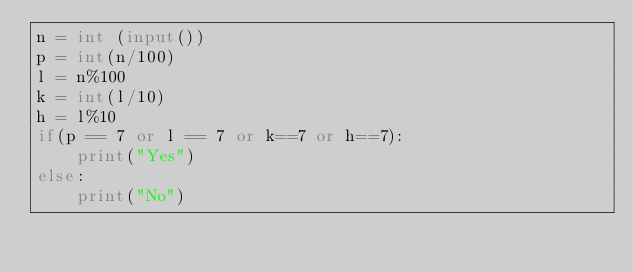Convert code to text. <code><loc_0><loc_0><loc_500><loc_500><_Python_>n = int (input())
p = int(n/100)
l = n%100
k = int(l/10)
h = l%10
if(p == 7 or l == 7 or k==7 or h==7):
    print("Yes")
else:
    print("No")

</code> 